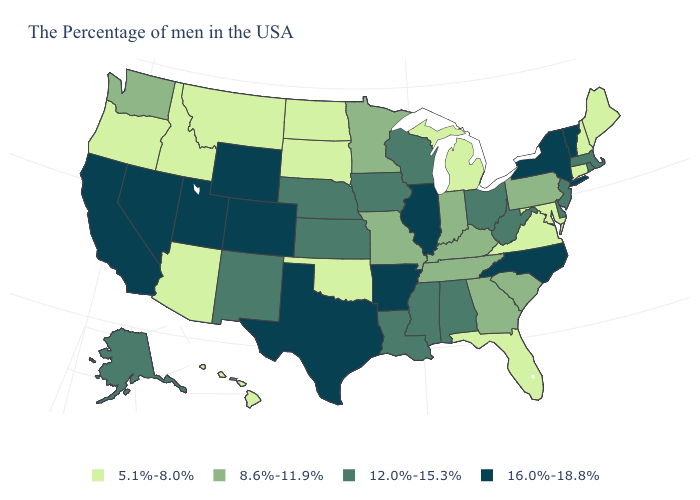Does the map have missing data?
Concise answer only. No. Which states have the highest value in the USA?
Answer briefly. Vermont, New York, North Carolina, Illinois, Arkansas, Texas, Wyoming, Colorado, Utah, Nevada, California. Name the states that have a value in the range 16.0%-18.8%?
Be succinct. Vermont, New York, North Carolina, Illinois, Arkansas, Texas, Wyoming, Colorado, Utah, Nevada, California. Name the states that have a value in the range 8.6%-11.9%?
Short answer required. Pennsylvania, South Carolina, Georgia, Kentucky, Indiana, Tennessee, Missouri, Minnesota, Washington. What is the lowest value in the West?
Answer briefly. 5.1%-8.0%. Does the map have missing data?
Write a very short answer. No. Does Texas have the same value as Vermont?
Answer briefly. Yes. Name the states that have a value in the range 12.0%-15.3%?
Keep it brief. Massachusetts, Rhode Island, New Jersey, Delaware, West Virginia, Ohio, Alabama, Wisconsin, Mississippi, Louisiana, Iowa, Kansas, Nebraska, New Mexico, Alaska. Does Colorado have the highest value in the USA?
Short answer required. Yes. Name the states that have a value in the range 8.6%-11.9%?
Concise answer only. Pennsylvania, South Carolina, Georgia, Kentucky, Indiana, Tennessee, Missouri, Minnesota, Washington. Is the legend a continuous bar?
Keep it brief. No. Does Illinois have a higher value than North Carolina?
Keep it brief. No. Name the states that have a value in the range 12.0%-15.3%?
Give a very brief answer. Massachusetts, Rhode Island, New Jersey, Delaware, West Virginia, Ohio, Alabama, Wisconsin, Mississippi, Louisiana, Iowa, Kansas, Nebraska, New Mexico, Alaska. Does Missouri have the highest value in the USA?
Write a very short answer. No. What is the value of Washington?
Be succinct. 8.6%-11.9%. 